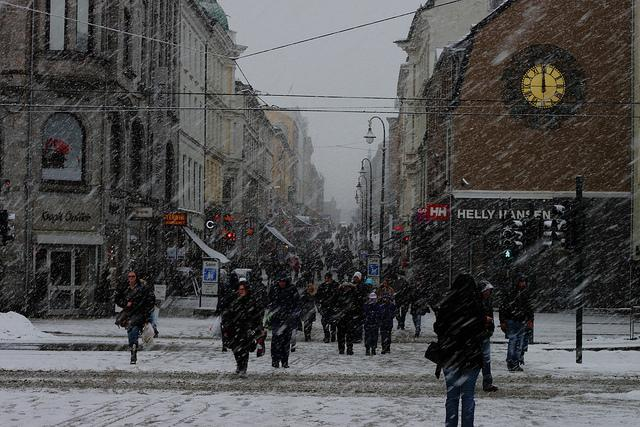What is the composition of the falling material? Please explain your reasoning. water. Basic science tells you that when water freezes it turns into ice, hail, and snow. 